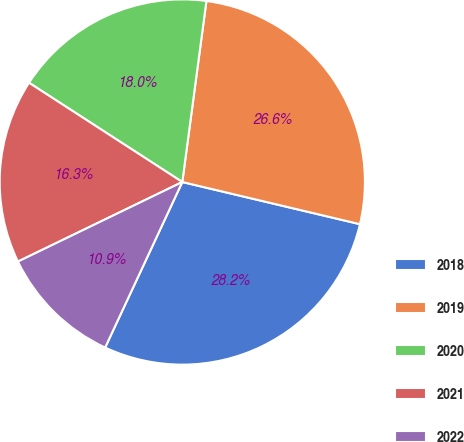Convert chart. <chart><loc_0><loc_0><loc_500><loc_500><pie_chart><fcel>2018<fcel>2019<fcel>2020<fcel>2021<fcel>2022<nl><fcel>28.23%<fcel>26.6%<fcel>17.96%<fcel>16.32%<fcel>10.88%<nl></chart> 